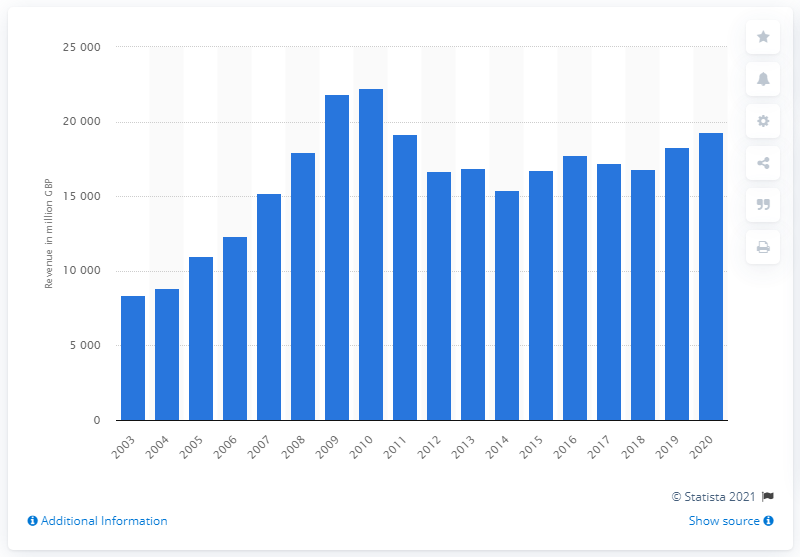Draw attention to some important aspects in this diagram. In 2020, the revenue of BAE Systems was 19,277. 